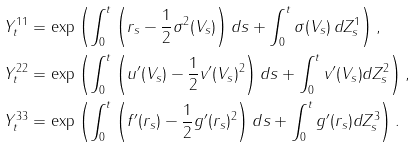Convert formula to latex. <formula><loc_0><loc_0><loc_500><loc_500>Y _ { t } ^ { 1 1 } & = \exp \left ( \int _ { 0 } ^ { t } { \left ( r _ { s } - \frac { 1 } { 2 } \sigma ^ { 2 } ( V _ { s } ) \right ) } \, d s + \int _ { 0 } ^ { t } { \sigma ( V _ { s } ) } \, d Z _ { s } ^ { 1 } \right ) , \\ Y _ { t } ^ { 2 2 } & = \exp \left ( \int _ { 0 } ^ { t } { \left ( u ^ { \prime } ( V _ { s } ) - \frac { 1 } { 2 } v ^ { \prime } ( V _ { s } ) ^ { 2 } \right ) } \, d s + \int _ { 0 } ^ { t } { v ^ { \prime } ( V _ { s } ) } d Z _ { s } ^ { 2 } \right ) , \\ Y _ { t } ^ { 3 3 } & = \exp \left ( \int _ { 0 } ^ { t } { \left ( f ^ { \prime } ( r _ { s } ) - \frac { 1 } { 2 } g ^ { \prime } ( r _ { s } ) ^ { 2 } \right ) } \, d s + \int _ { 0 } ^ { t } { g ^ { \prime } ( r _ { s } ) } d Z _ { s } ^ { 3 } \right ) .</formula> 